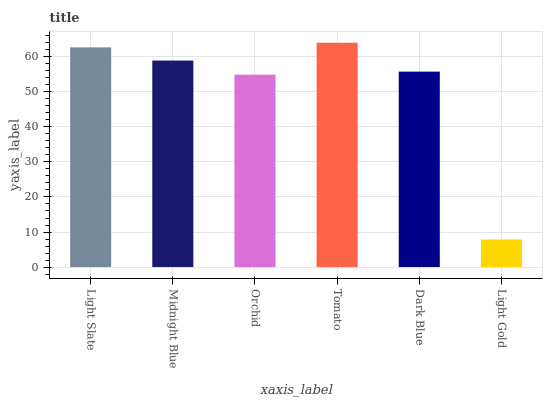Is Light Gold the minimum?
Answer yes or no. Yes. Is Tomato the maximum?
Answer yes or no. Yes. Is Midnight Blue the minimum?
Answer yes or no. No. Is Midnight Blue the maximum?
Answer yes or no. No. Is Light Slate greater than Midnight Blue?
Answer yes or no. Yes. Is Midnight Blue less than Light Slate?
Answer yes or no. Yes. Is Midnight Blue greater than Light Slate?
Answer yes or no. No. Is Light Slate less than Midnight Blue?
Answer yes or no. No. Is Midnight Blue the high median?
Answer yes or no. Yes. Is Dark Blue the low median?
Answer yes or no. Yes. Is Light Slate the high median?
Answer yes or no. No. Is Tomato the low median?
Answer yes or no. No. 